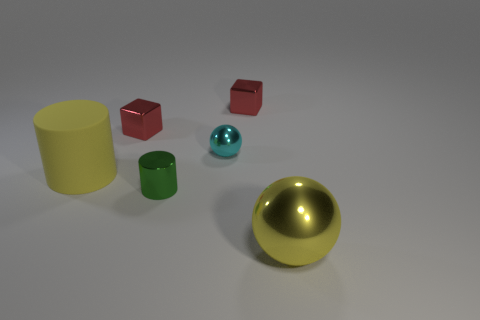Subtract all green cylinders. How many cylinders are left? 1 Subtract 1 cylinders. How many cylinders are left? 1 Add 3 small red blocks. How many objects exist? 9 Subtract all balls. How many objects are left? 4 Subtract all small red cubes. Subtract all blocks. How many objects are left? 2 Add 6 red shiny things. How many red shiny things are left? 8 Add 4 big gray rubber balls. How many big gray rubber balls exist? 4 Subtract 0 green cubes. How many objects are left? 6 Subtract all green balls. Subtract all purple cylinders. How many balls are left? 2 